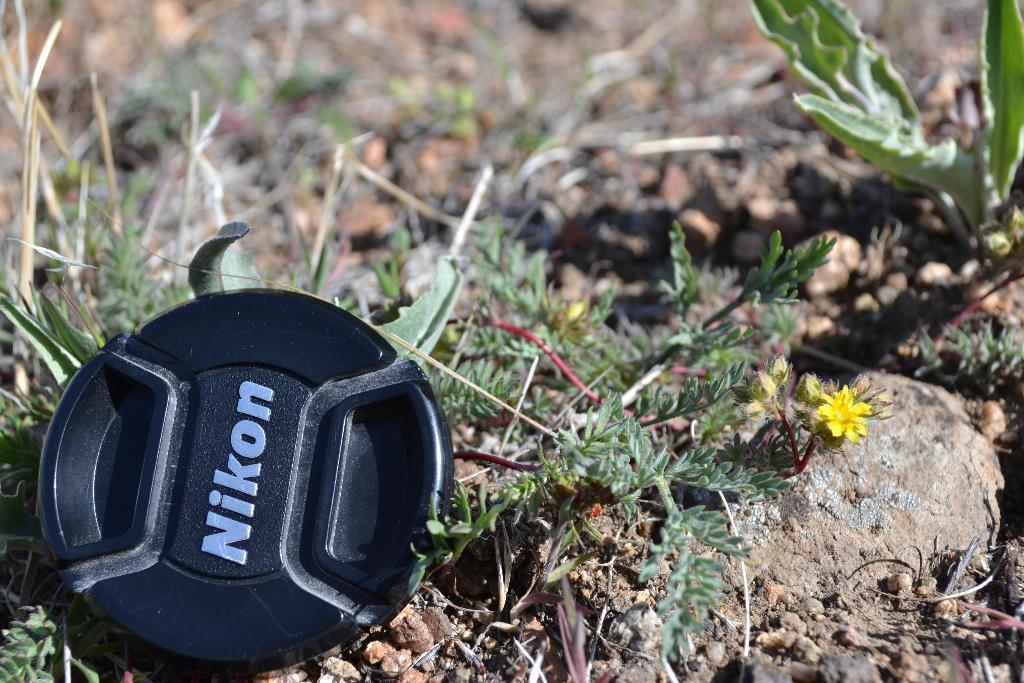What type of vegetation can be seen in the image? There is grass around the area of the image. Can you describe the environment in the image? The environment in the image is characterized by grass, suggesting an outdoor or natural setting. What type of bait is being used to catch fish in the image? There is no mention of fish or bait in the image; it only features grass. 